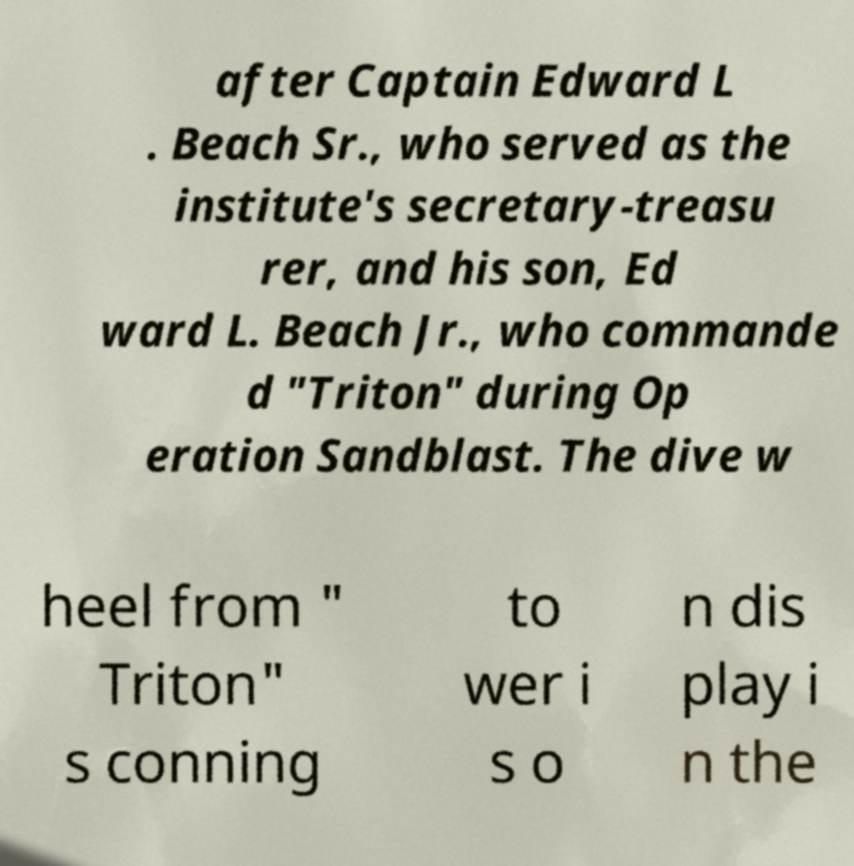Can you accurately transcribe the text from the provided image for me? after Captain Edward L . Beach Sr., who served as the institute's secretary-treasu rer, and his son, Ed ward L. Beach Jr., who commande d "Triton" during Op eration Sandblast. The dive w heel from " Triton" s conning to wer i s o n dis play i n the 